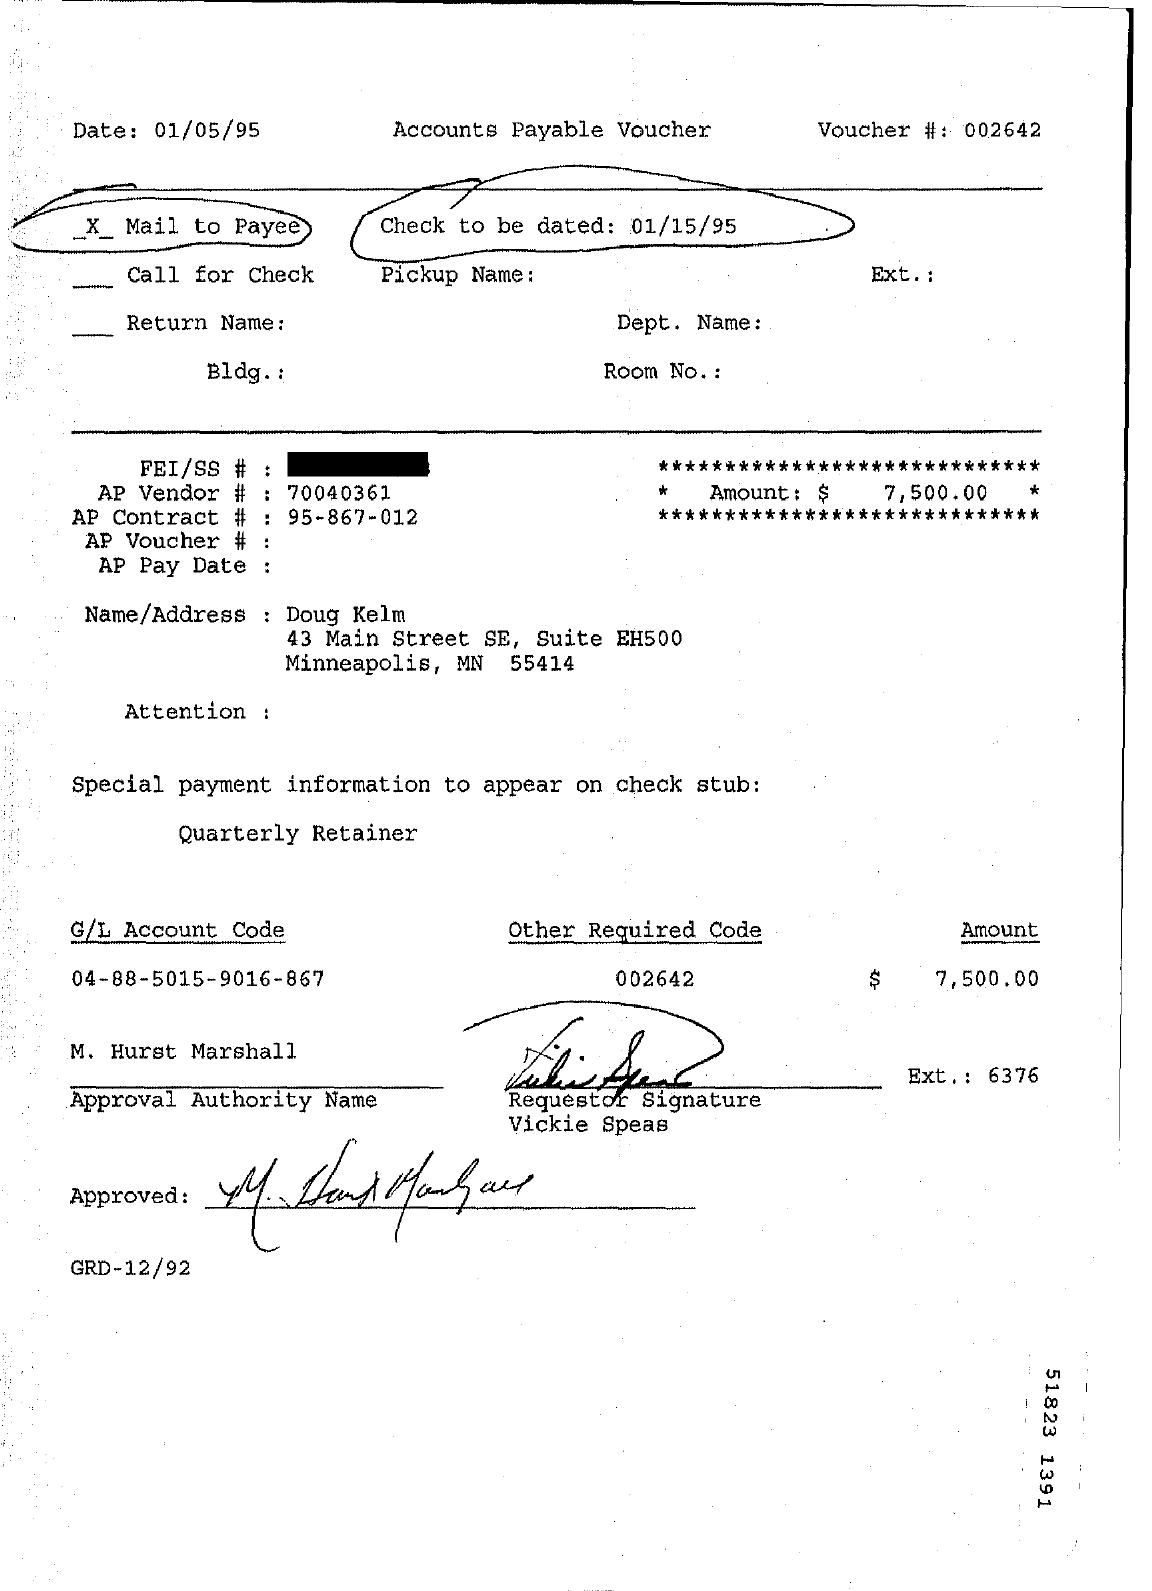Give some essential details in this illustration. What is the GL Account Code? It is 04-88-5015-9016-867... The date mentioned in the top left of the document is 01/05/95. The AP contract number is 95-867-012. I am being offered $7,500.00 in compensation for my services. This document appears to be an Accounts Payable Voucher. 